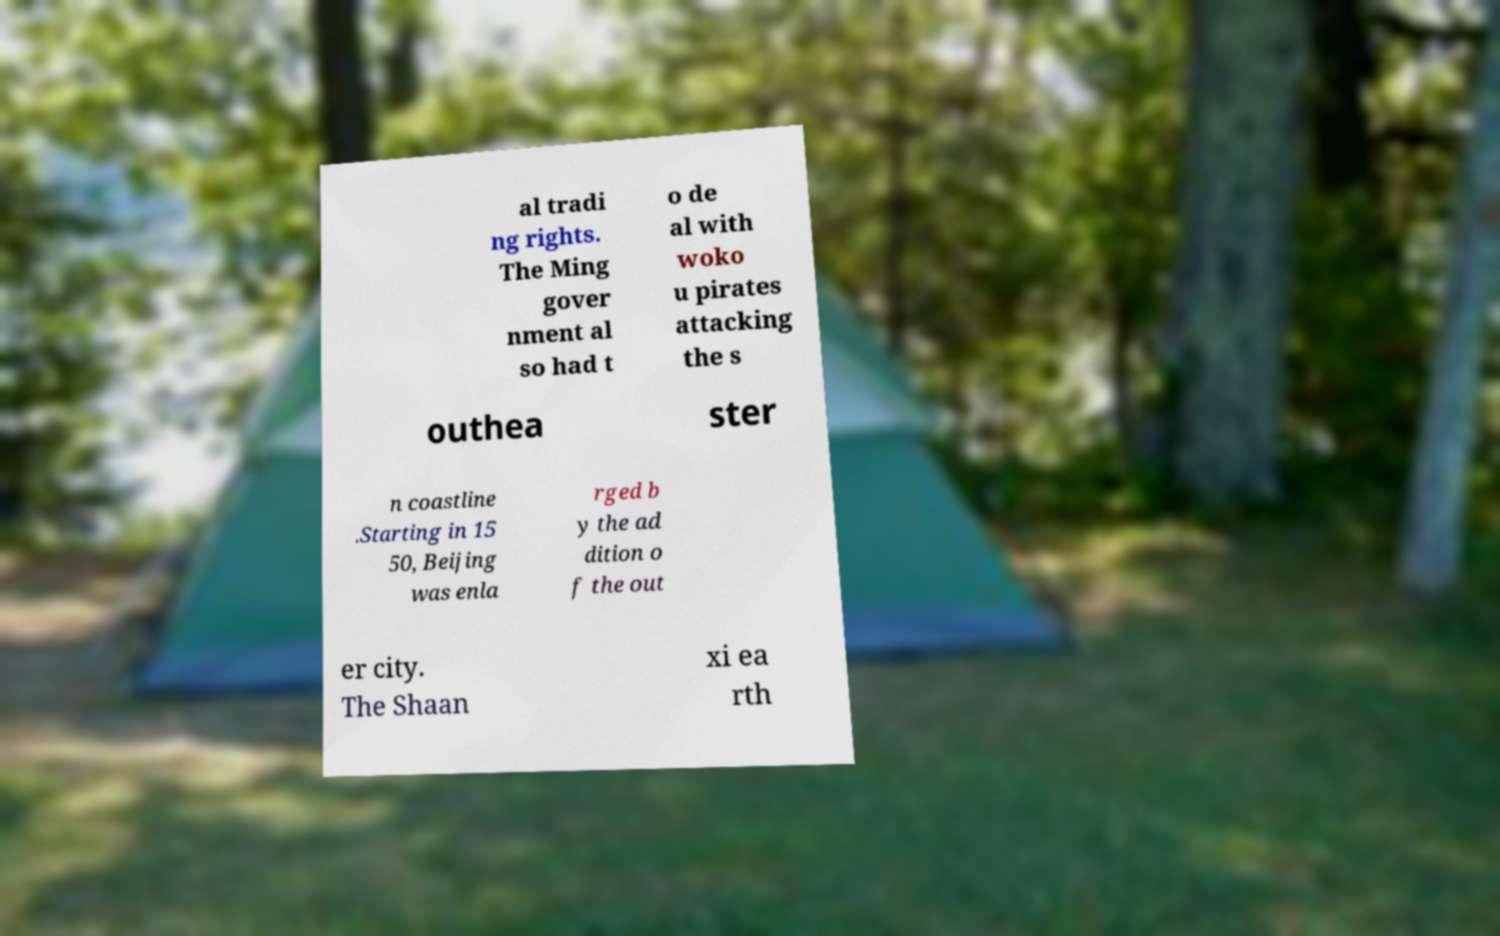There's text embedded in this image that I need extracted. Can you transcribe it verbatim? al tradi ng rights. The Ming gover nment al so had t o de al with woko u pirates attacking the s outhea ster n coastline .Starting in 15 50, Beijing was enla rged b y the ad dition o f the out er city. The Shaan xi ea rth 